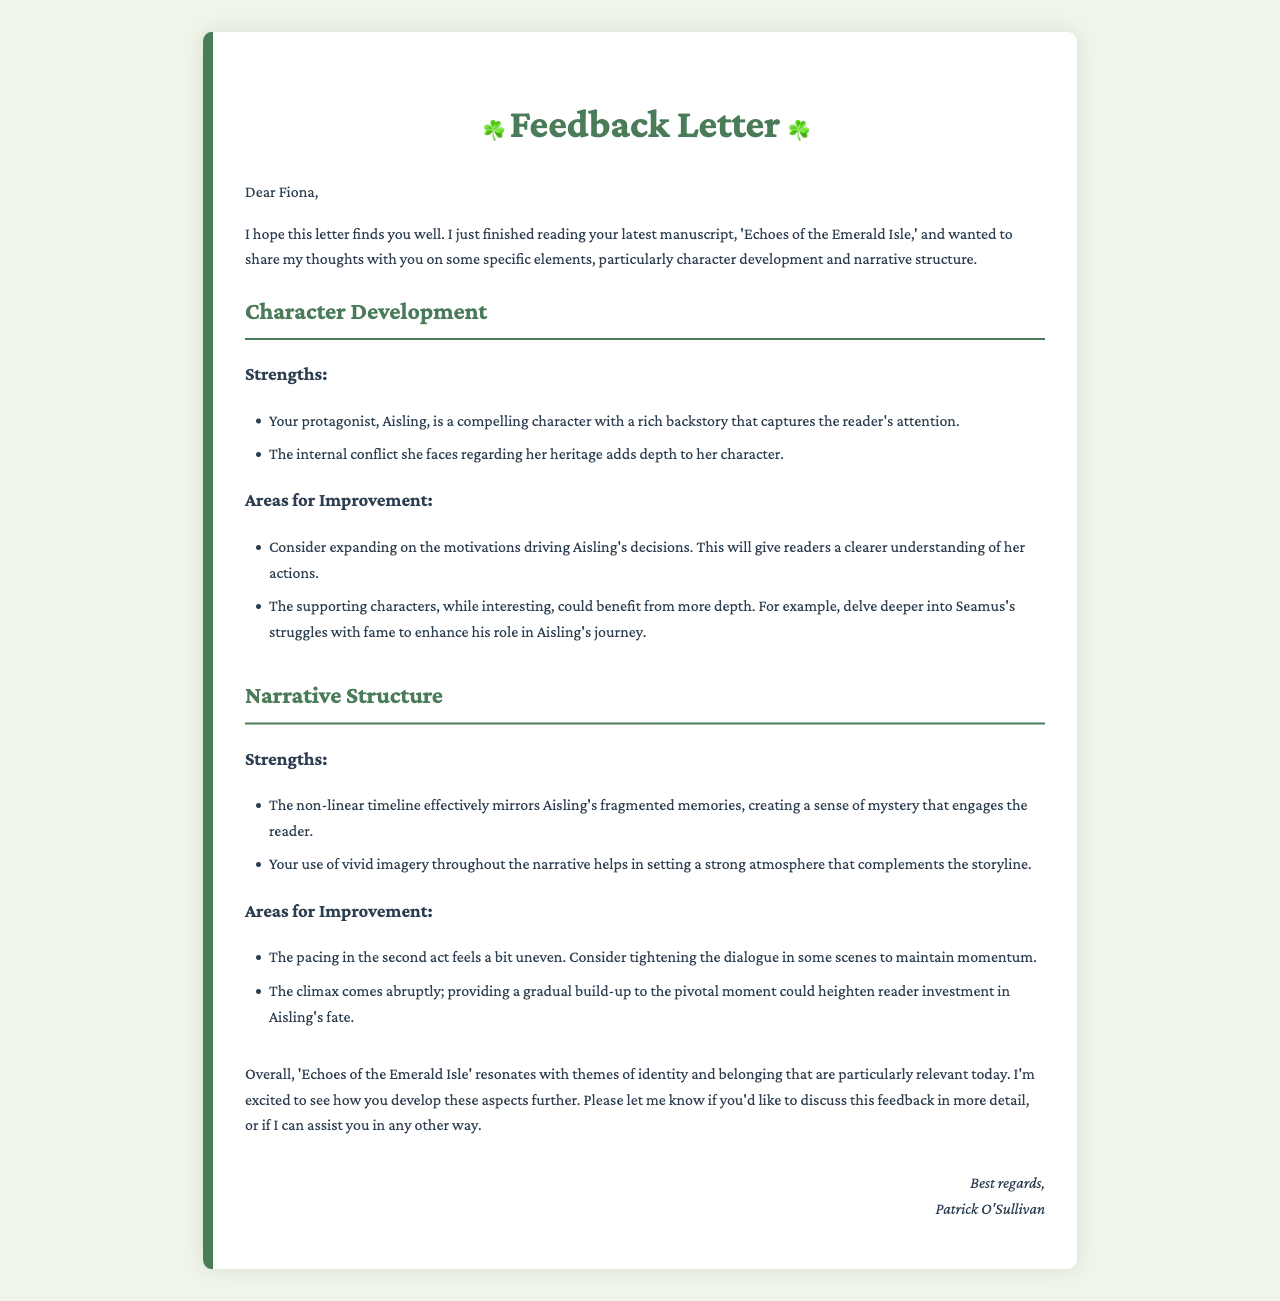What is the title of the manuscript? The title of the manuscript is mentioned in the introduction of the letter as 'Echoes of the Emerald Isle.'
Answer: Echoes of the Emerald Isle Who is the protagonist of the story? The protagonist is identified in the character development section as Aisling.
Answer: Aisling What is a strength of the narrative structure? A specific strength mentioned in the document is the use of a non-linear timeline that effectively mirrors Aisling's fragmented memories.
Answer: Non-linear timeline What area for improvement is suggested for supporting characters? The feedback suggests delving deeper into Seamus's struggles with fame to enhance his role.
Answer: Seamus's struggles with fame What feeling does the author aim to evoke through the climax? The document discusses heightening reader investment in Aisling's fate as a goal for the climax.
Answer: Investment in Aisling's fate What does Patrick O'Sullivan express excitement about? Patrick expresses excitement about the development of themes of identity and belonging in the manuscript.
Answer: Themes of identity and belonging 